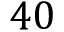<formula> <loc_0><loc_0><loc_500><loc_500>4 0</formula> 